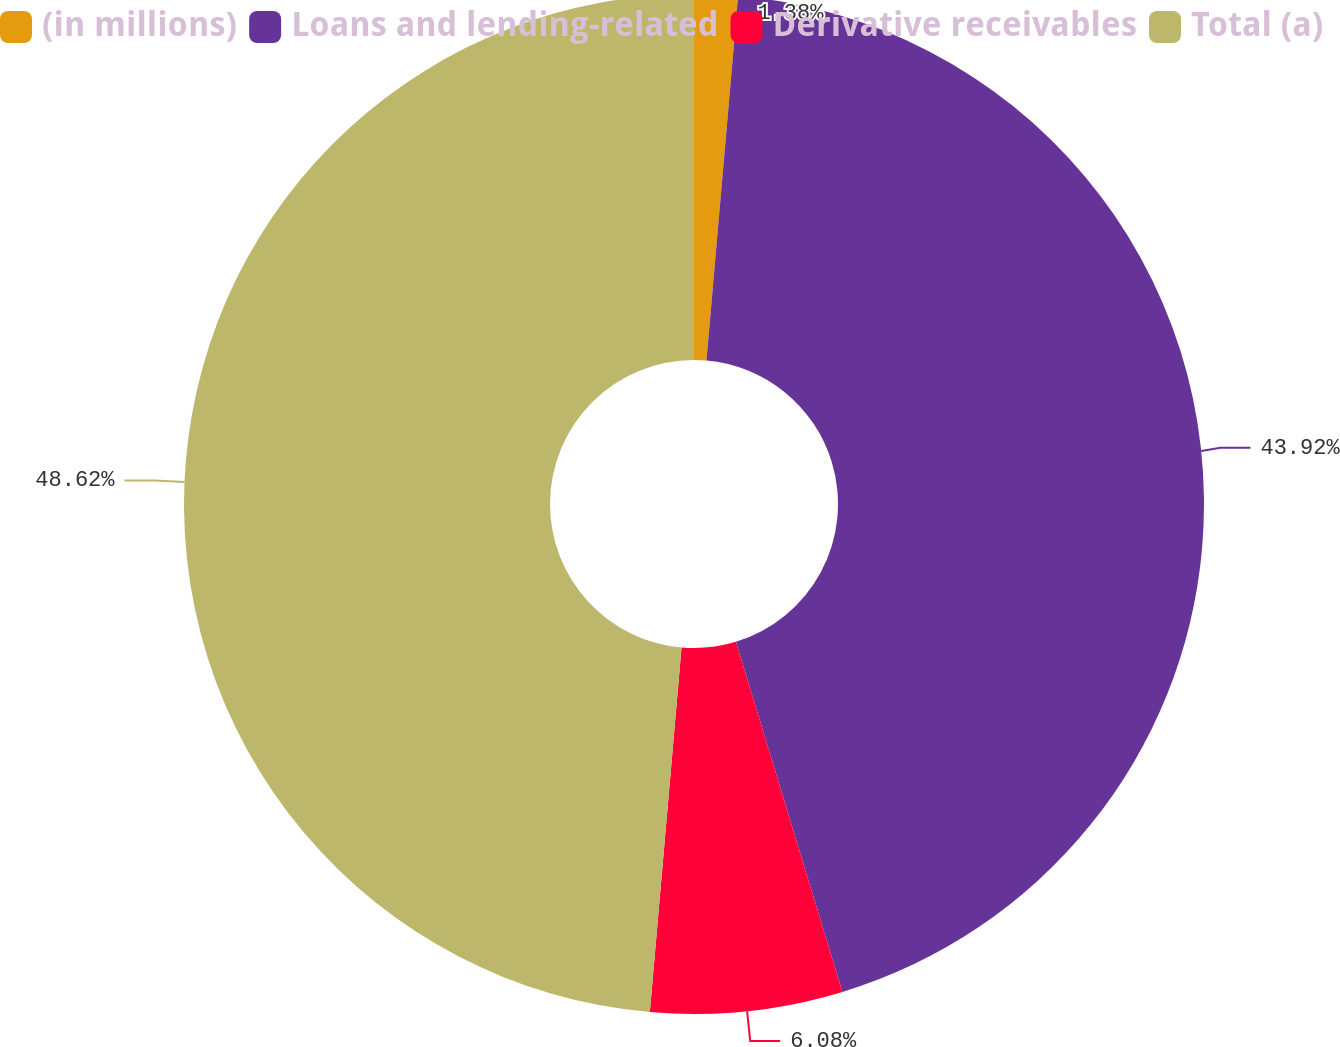<chart> <loc_0><loc_0><loc_500><loc_500><pie_chart><fcel>(in millions)<fcel>Loans and lending-related<fcel>Derivative receivables<fcel>Total (a)<nl><fcel>1.38%<fcel>43.92%<fcel>6.08%<fcel>48.62%<nl></chart> 